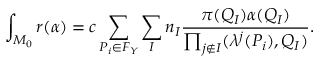Convert formula to latex. <formula><loc_0><loc_0><loc_500><loc_500>\int _ { M _ { 0 } } r ( \alpha ) = c \sum _ { P _ { i } \in F _ { Y } } \sum _ { I } n _ { I } \frac { \pi ( Q _ { I } ) \alpha ( Q _ { I } ) } { \prod _ { j \notin I } ( \lambda ^ { j } ( P _ { i } ) , Q _ { I } ) } .</formula> 